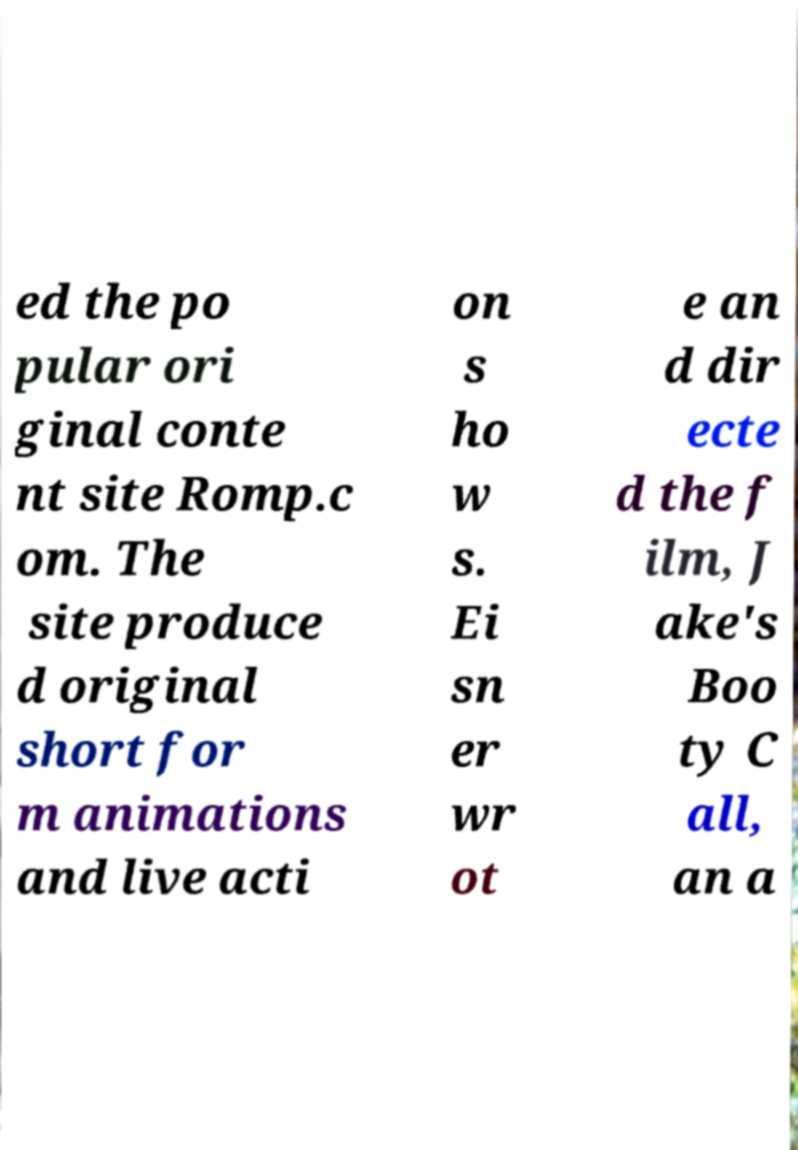Could you extract and type out the text from this image? ed the po pular ori ginal conte nt site Romp.c om. The site produce d original short for m animations and live acti on s ho w s. Ei sn er wr ot e an d dir ecte d the f ilm, J ake's Boo ty C all, an a 